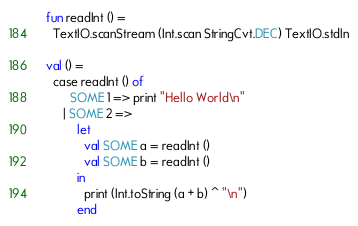Convert code to text. <code><loc_0><loc_0><loc_500><loc_500><_OCaml_>fun readInt () =
  TextIO.scanStream (Int.scan StringCvt.DEC) TextIO.stdIn

val () =
  case readInt () of
       SOME 1 => print "Hello World\n"
     | SOME 2 =>
         let
           val SOME a = readInt ()
           val SOME b = readInt ()
         in
           print (Int.toString (a + b) ^ "\n")
         end
</code> 